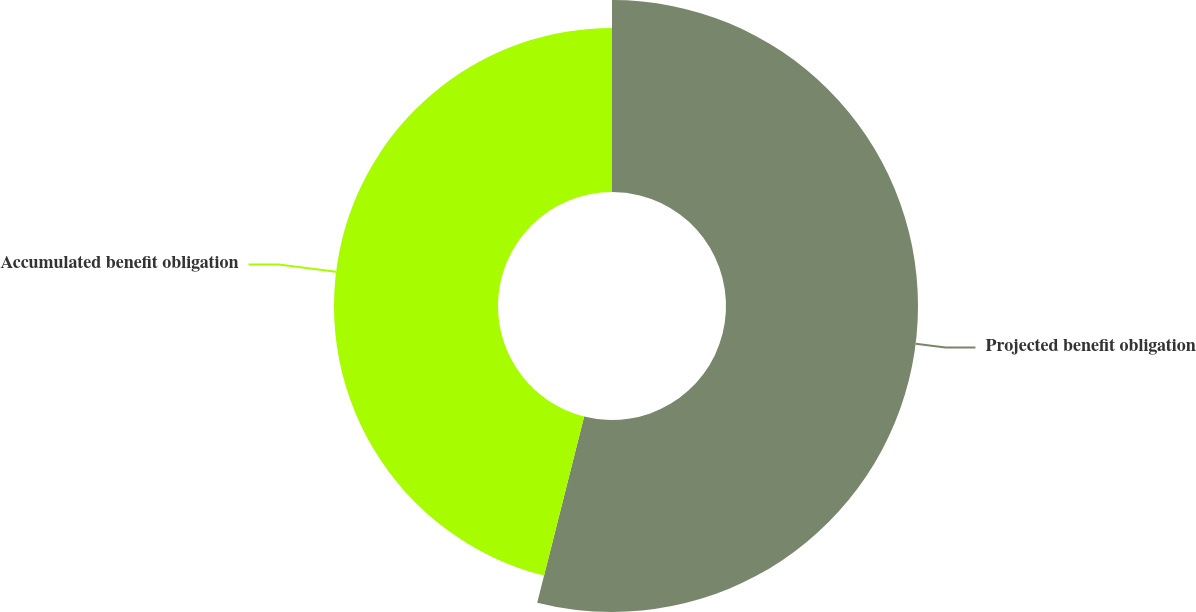Convert chart to OTSL. <chart><loc_0><loc_0><loc_500><loc_500><pie_chart><fcel>Projected benefit obligation<fcel>Accumulated benefit obligation<nl><fcel>53.93%<fcel>46.07%<nl></chart> 